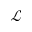Convert formula to latex. <formula><loc_0><loc_0><loc_500><loc_500>\mathcal { L }</formula> 